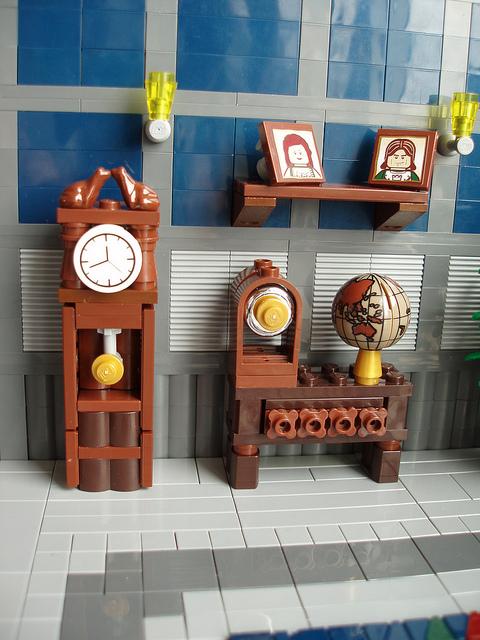What is this scene made of?
Quick response, please. Legos. Is there a globe in the picture?
Concise answer only. Yes. Is there a shadow in the scene?
Answer briefly. Yes. 